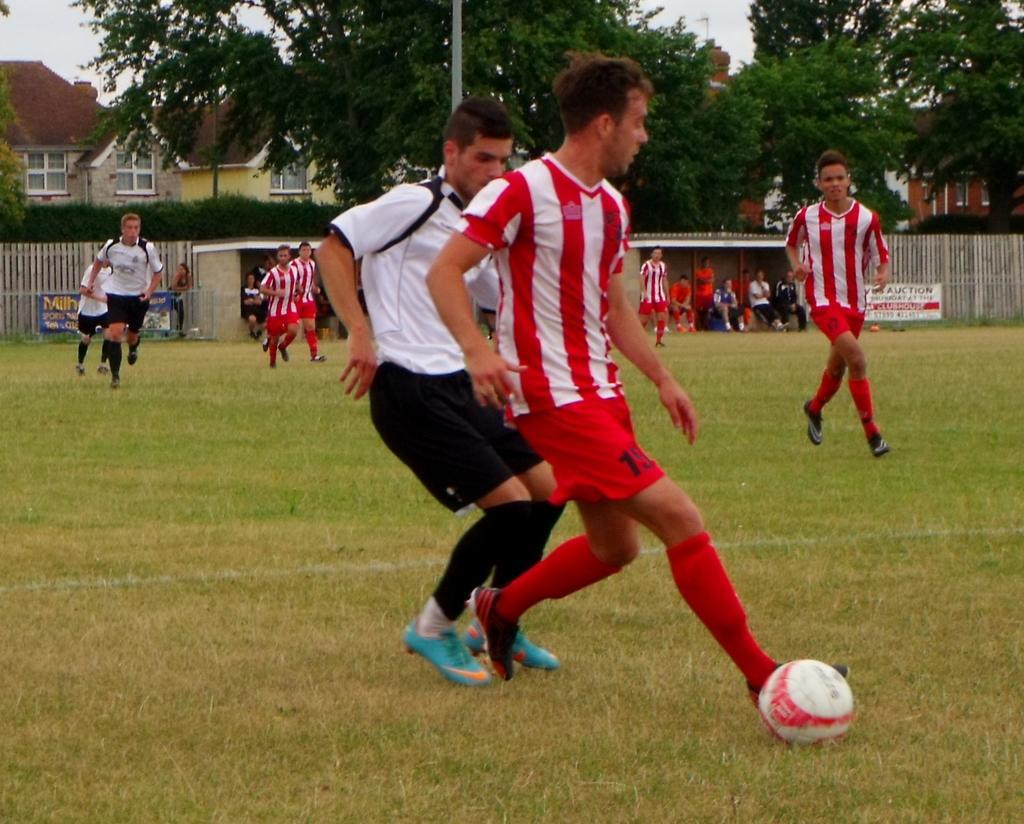How would you summarize this image in a sentence or two? This image is clicked in a ground. There are many people playing the game. In the front, the man wearing red dress is about to kick the ball. At the bottom, there is green grass. In the background, there are trees and buildings. 